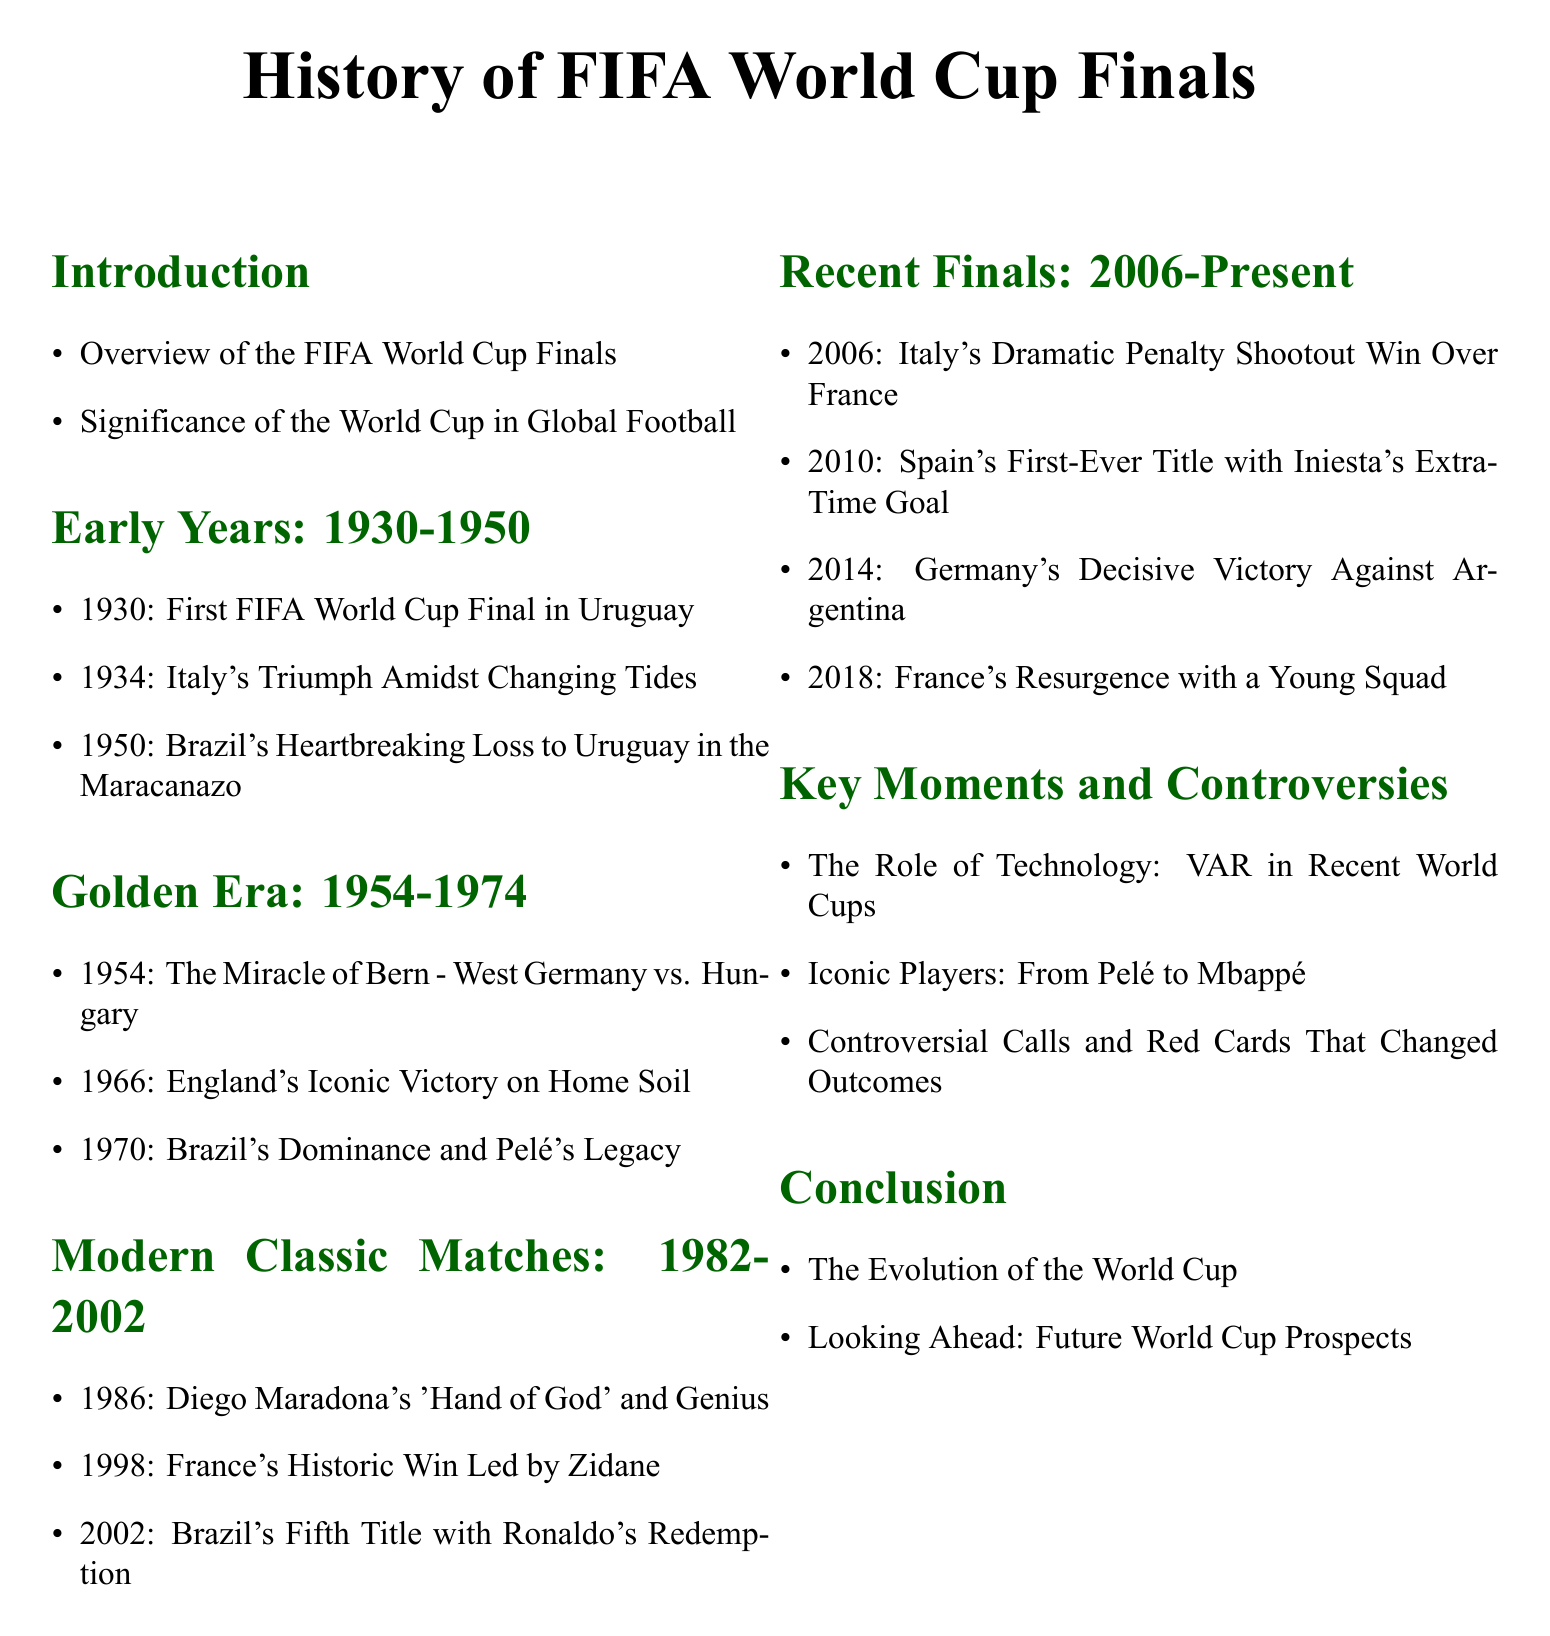What year was the first FIFA World Cup Final held? The document states that the first FIFA World Cup Final was held in 1930.
Answer: 1930 Which country won the 1966 FIFA World Cup Final? According to the document, England won the 1966 FIFA World Cup Final.
Answer: England What notable event occurred in the 1950 World Cup Final? The document mentions Brazil's heartbreaking loss to Uruguay, known as the Maracanazo.
Answer: Maracanazo What is the significance of VAR in recent World Cups? The document highlights the role of technology, specifically VAR, in recent World Cups as a key moment.
Answer: VAR Who is mentioned as a player associated with Brazil's 1970 team? The document cites Pelé as a significant player during Brazil's dominance in 1970.
Answer: Pelé What year did France win their first World Cup title? The document states that France won their first title in 2010.
Answer: 2010 Which match is referred to as "The Miracle of Bern"? The document refers to the 1954 match between West Germany and Hungary.
Answer: West Germany vs. Hungary What theme is addressed in the "Key Moments and Controversies" section? The document discusses several themes including controversial calls and technological impact.
Answer: Controversial calls Which country's squad is described in the 2018 World Cup Final? The document refers to a young squad from France in the 2018 final.
Answer: France 